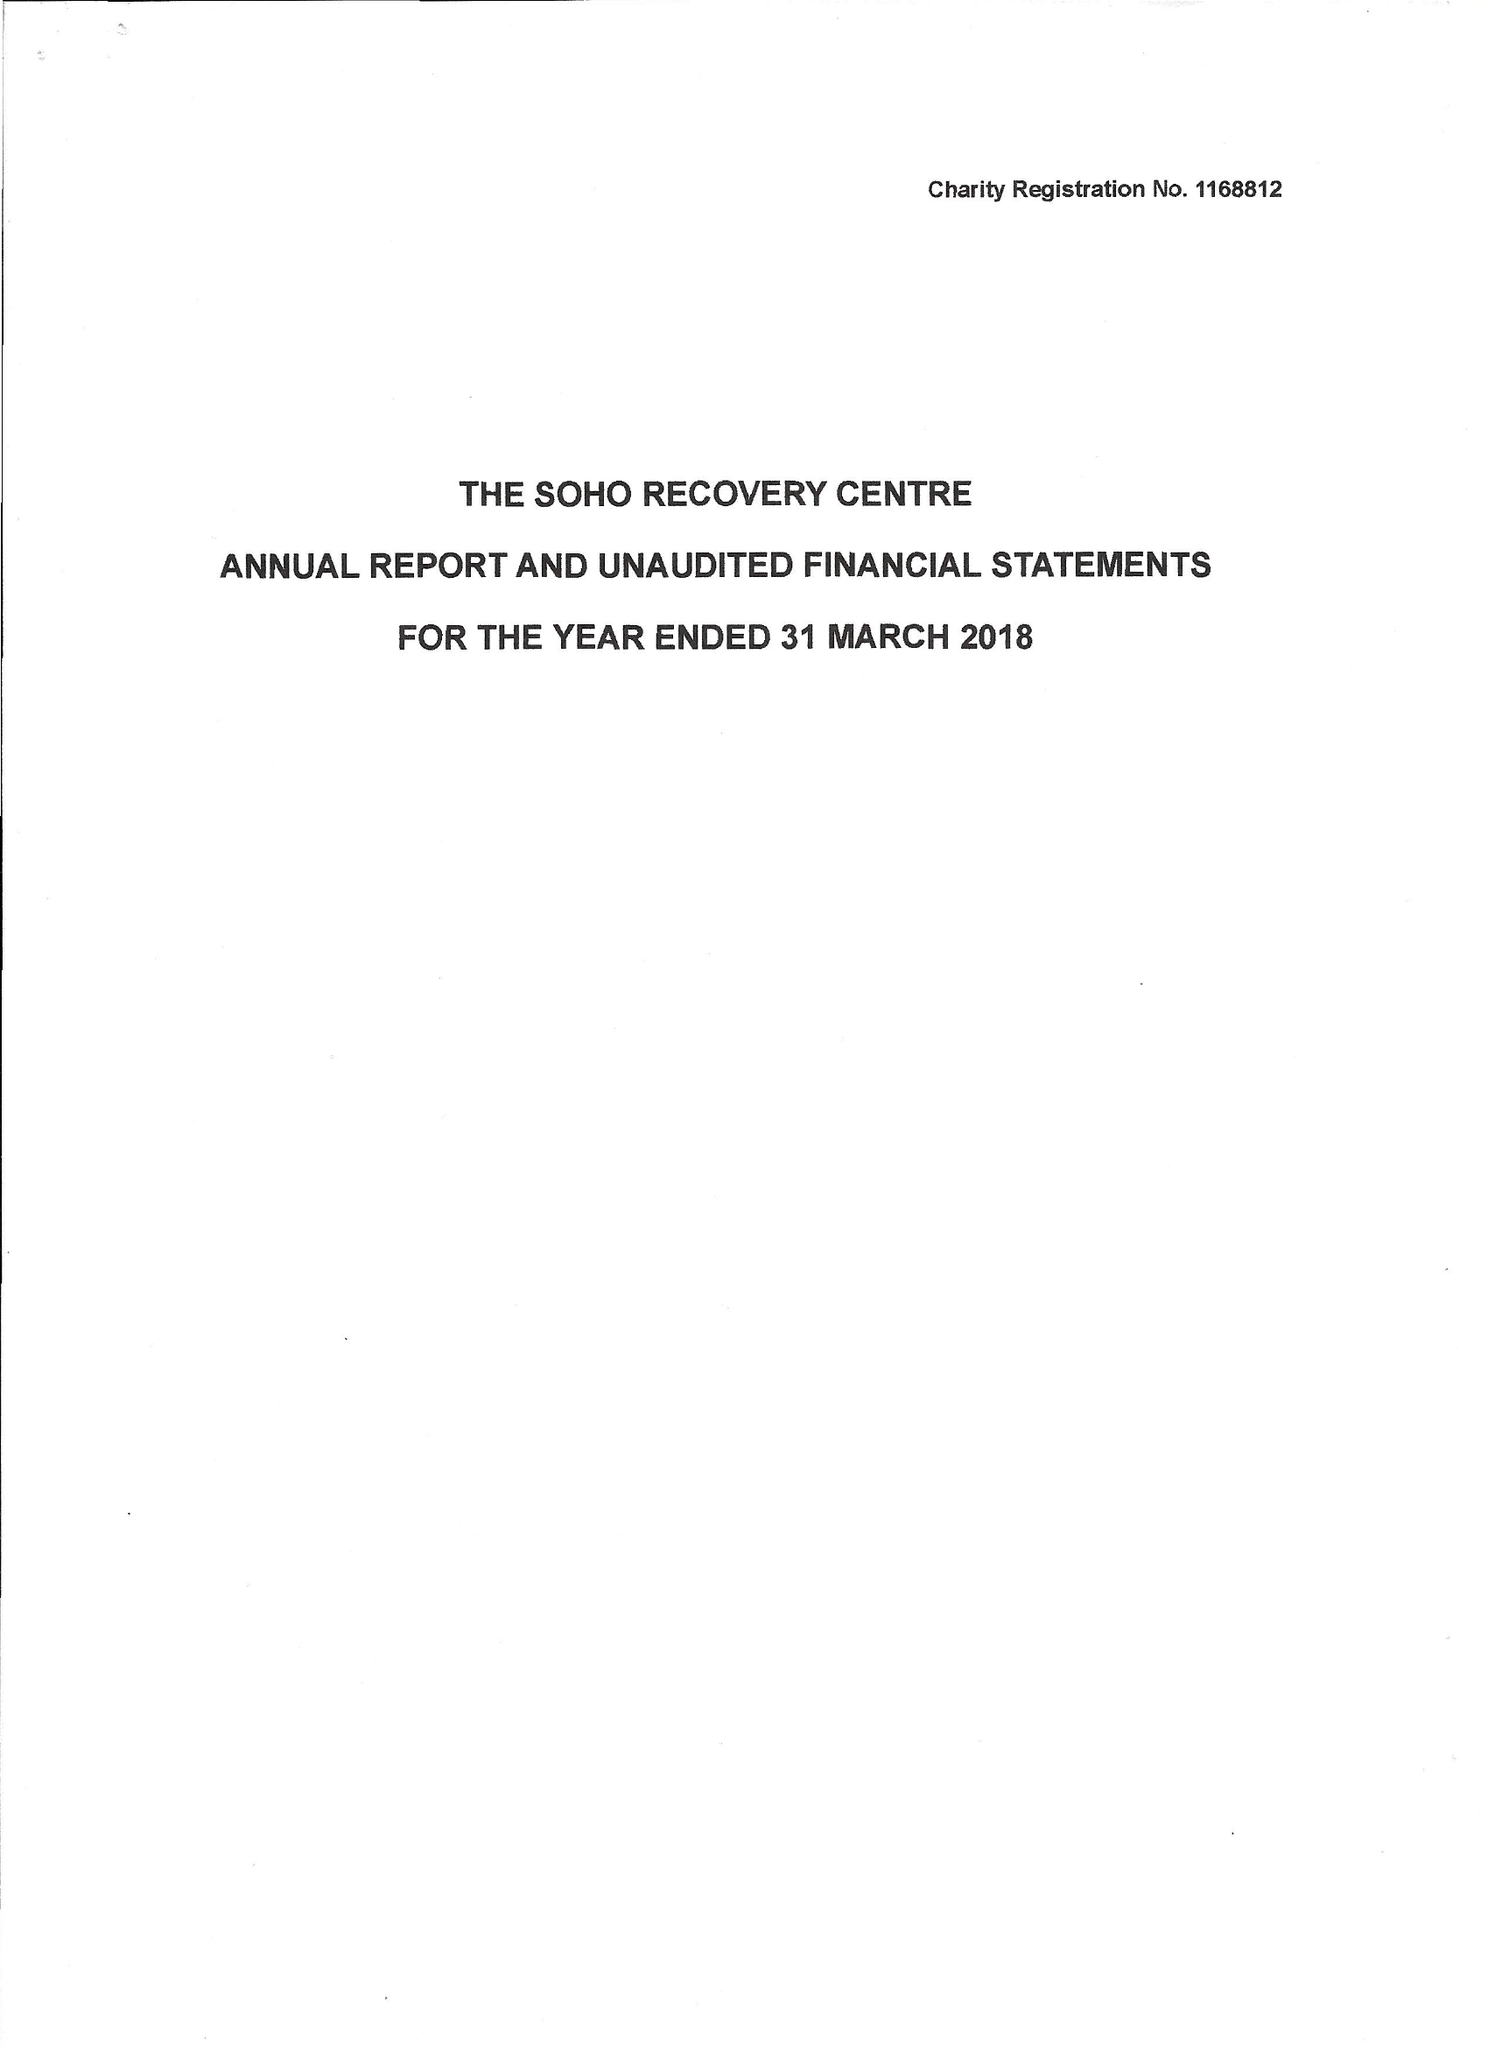What is the value for the income_annually_in_british_pounds?
Answer the question using a single word or phrase. 94548.00 